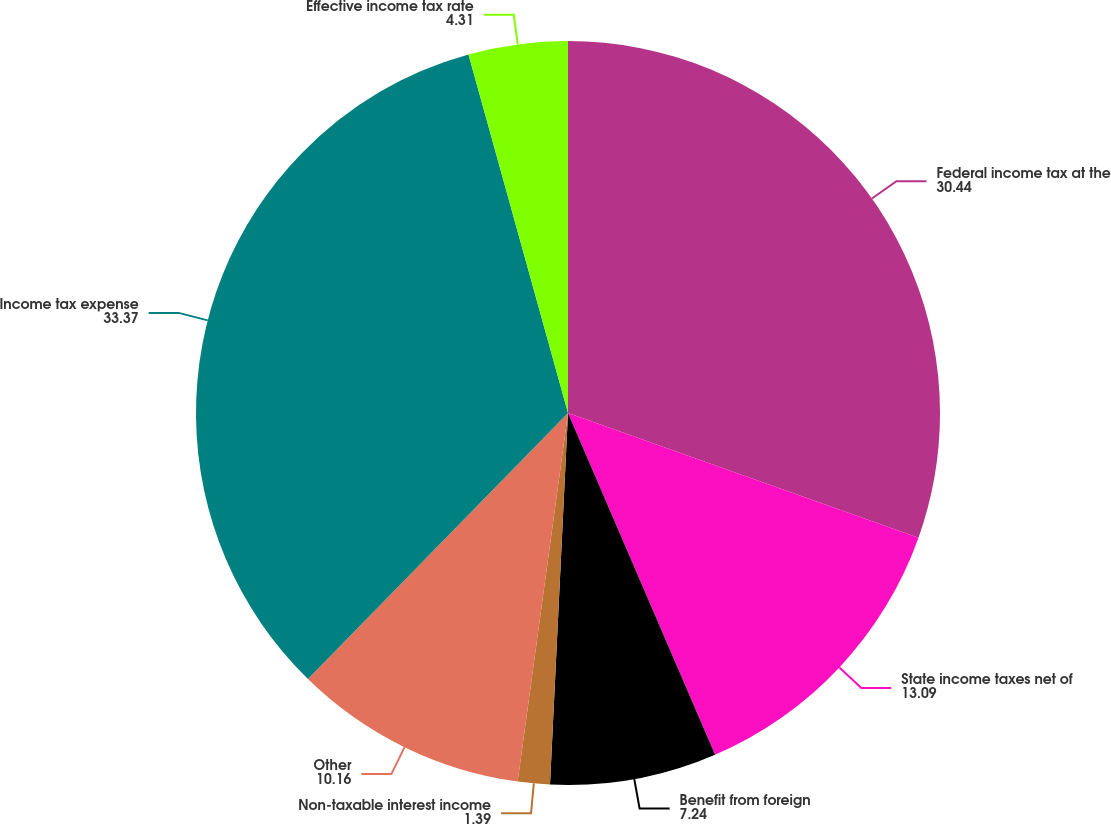Convert chart. <chart><loc_0><loc_0><loc_500><loc_500><pie_chart><fcel>Federal income tax at the<fcel>State income taxes net of<fcel>Benefit from foreign<fcel>Non-taxable interest income<fcel>Other<fcel>Income tax expense<fcel>Effective income tax rate<nl><fcel>30.44%<fcel>13.09%<fcel>7.24%<fcel>1.39%<fcel>10.16%<fcel>33.37%<fcel>4.31%<nl></chart> 